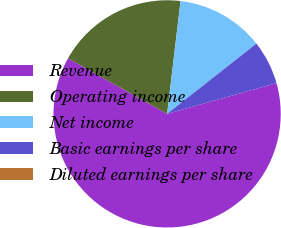<chart> <loc_0><loc_0><loc_500><loc_500><pie_chart><fcel>Revenue<fcel>Operating income<fcel>Net income<fcel>Basic earnings per share<fcel>Diluted earnings per share<nl><fcel>62.5%<fcel>18.75%<fcel>12.5%<fcel>6.25%<fcel>0.0%<nl></chart> 